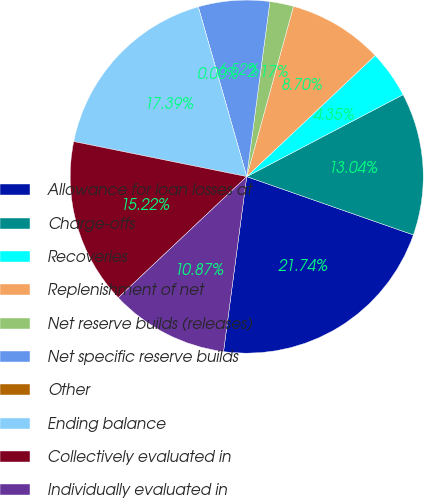<chart> <loc_0><loc_0><loc_500><loc_500><pie_chart><fcel>Allowance for loan losses at<fcel>Charge-offs<fcel>Recoveries<fcel>Replenishment of net<fcel>Net reserve builds (releases)<fcel>Net specific reserve builds<fcel>Other<fcel>Ending balance<fcel>Collectively evaluated in<fcel>Individually evaluated in<nl><fcel>21.74%<fcel>13.04%<fcel>4.35%<fcel>8.7%<fcel>2.17%<fcel>6.52%<fcel>0.0%<fcel>17.39%<fcel>15.22%<fcel>10.87%<nl></chart> 